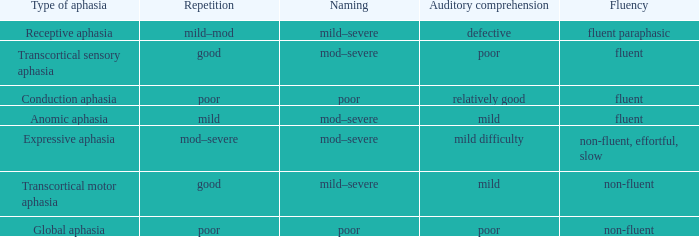Determine the fluency associated with transcortical sensory aphasia. Fluent. 